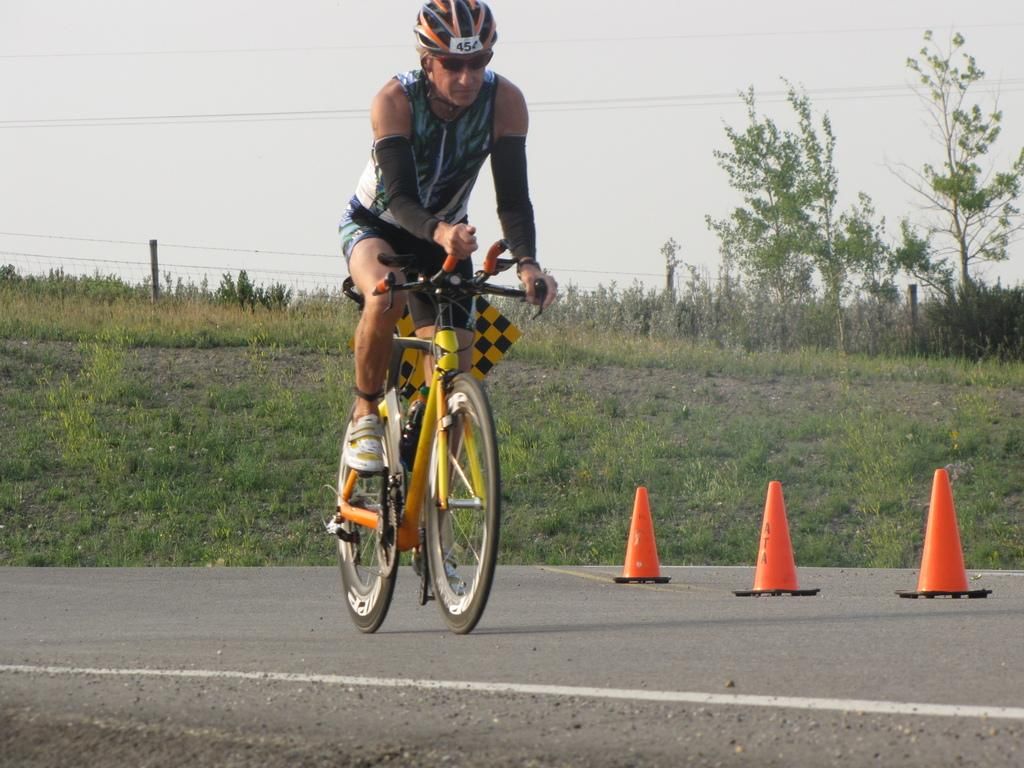What is the man in the image doing? The man is riding a bicycle in the image. Where is the man located in the image? The man is on the road in the image. What safety precaution is the man taking while riding the bicycle? The man is wearing a helmet in the image. What can be seen in the background of the image? There are trees in the background of the image. What objects are present to divide the road in the image? There are road divide objects in the image. What type of rose is the man holding in his hand while riding the bicycle? There is no rose present in the image; the man is riding a bicycle and wearing a helmet. 